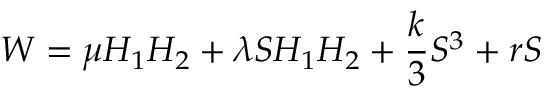<formula> <loc_0><loc_0><loc_500><loc_500>W = \mu H _ { 1 } H _ { 2 } + \lambda S H _ { 1 } H _ { 2 } + \frac { k } { 3 } S ^ { 3 } + r S</formula> 